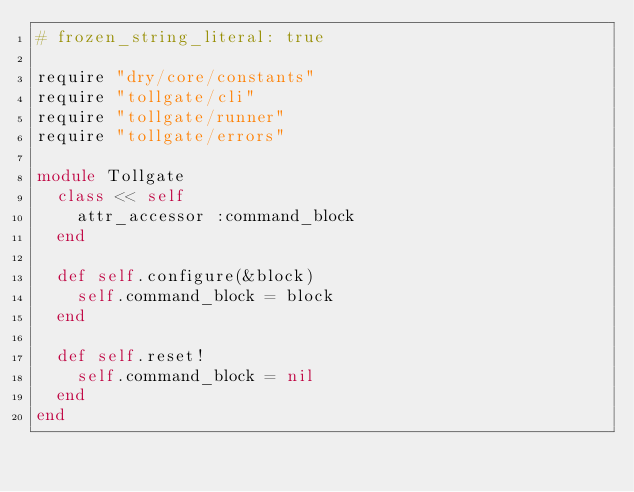<code> <loc_0><loc_0><loc_500><loc_500><_Ruby_># frozen_string_literal: true

require "dry/core/constants"
require "tollgate/cli"
require "tollgate/runner"
require "tollgate/errors"

module Tollgate
  class << self
    attr_accessor :command_block
  end

  def self.configure(&block)
    self.command_block = block
  end

  def self.reset!
    self.command_block = nil
  end
end
</code> 